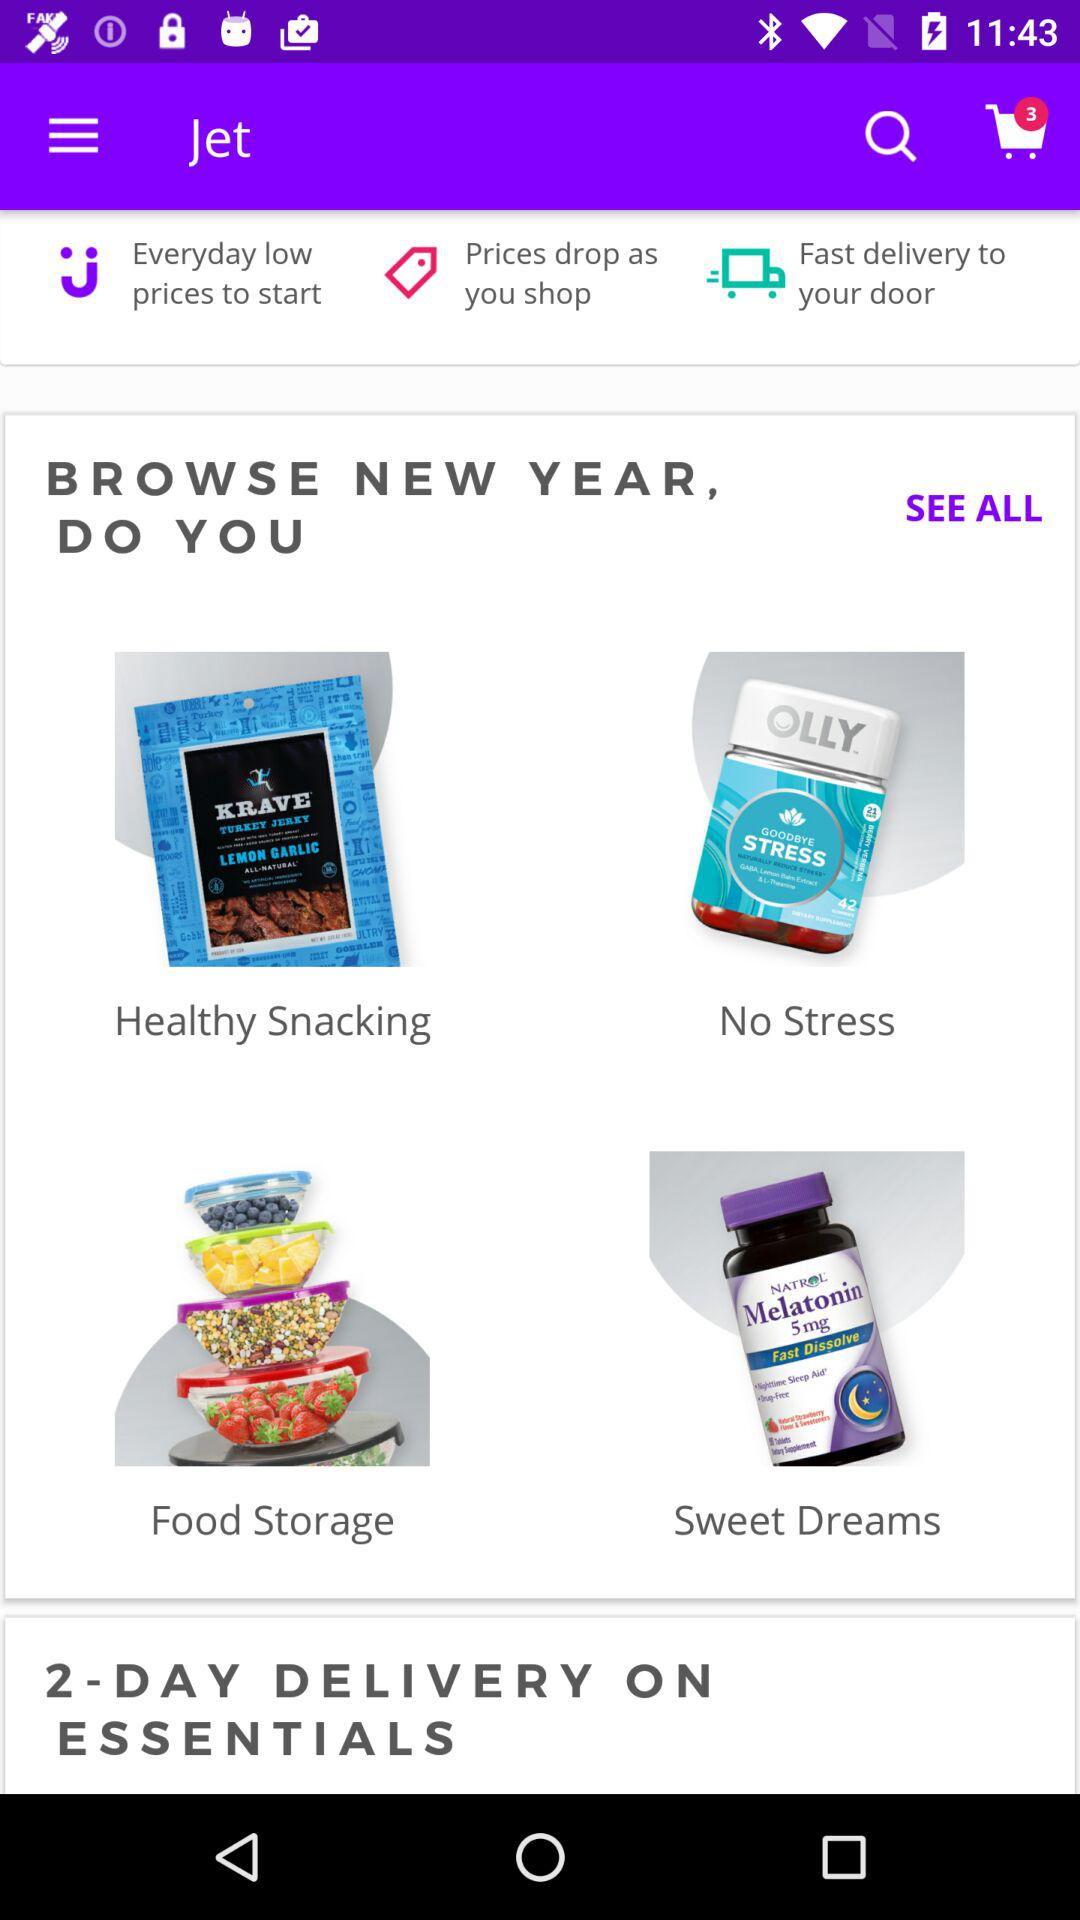How many products were in the cart? There were 3 products. 